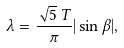Convert formula to latex. <formula><loc_0><loc_0><loc_500><loc_500>\lambda = \frac { \sqrt { 5 } \, T } { \pi } | \sin \beta | ,</formula> 